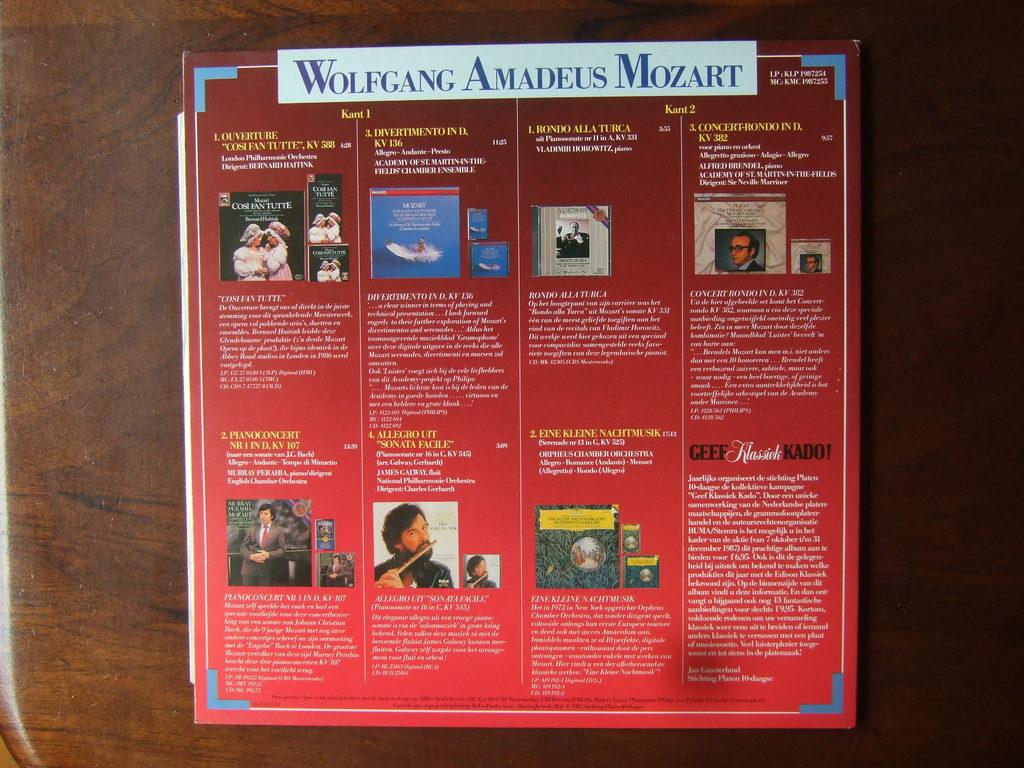Provide a one-sentence caption for the provided image. an item that has Wolfgang Amadeus Mozart at the top. 